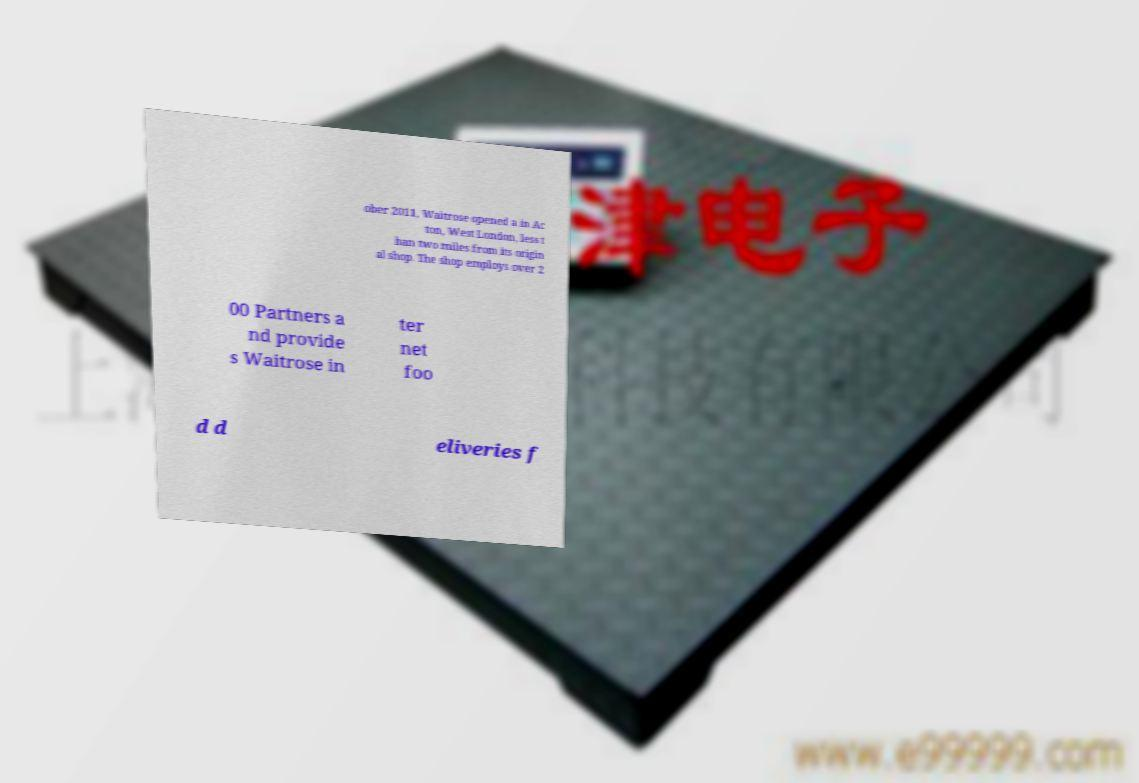Can you read and provide the text displayed in the image?This photo seems to have some interesting text. Can you extract and type it out for me? ober 2011, Waitrose opened a in Ac ton, West London, less t han two miles from its origin al shop. The shop employs over 2 00 Partners a nd provide s Waitrose in ter net foo d d eliveries f 